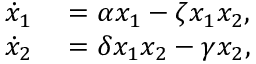<formula> <loc_0><loc_0><loc_500><loc_500>\begin{array} { r l } { \dot { x } _ { 1 } } & = \alpha x _ { 1 } - \zeta x _ { 1 } x _ { 2 } , } \\ { \dot { x } _ { 2 } } & = \delta x _ { 1 } x _ { 2 } - \gamma x _ { 2 } , } \end{array}</formula> 